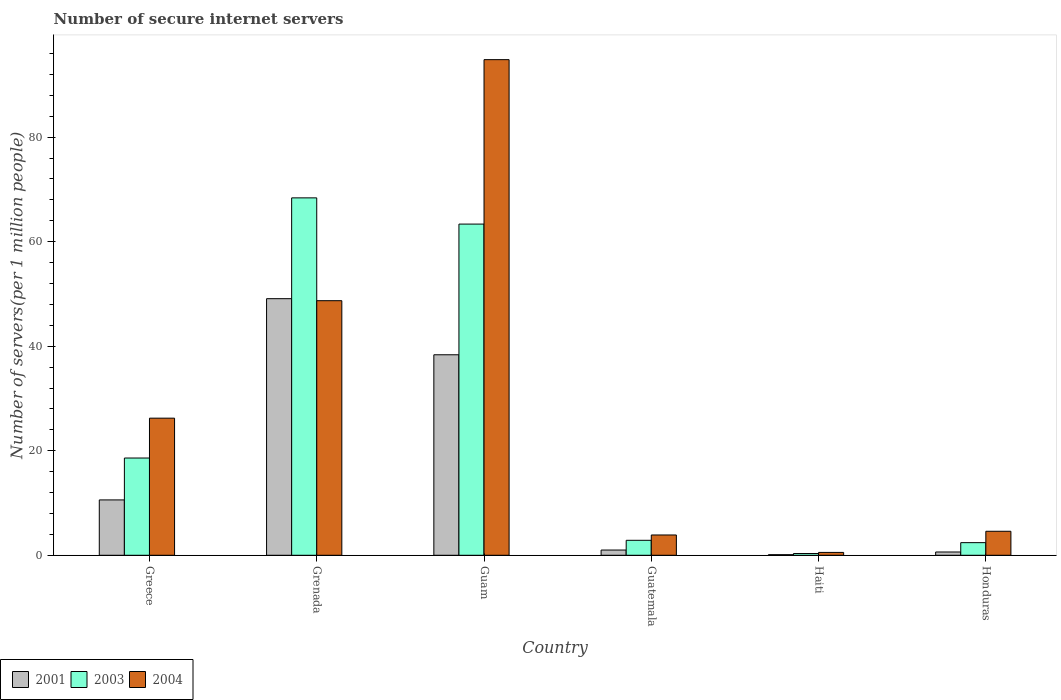Are the number of bars on each tick of the X-axis equal?
Your answer should be very brief. Yes. How many bars are there on the 4th tick from the right?
Offer a very short reply. 3. What is the label of the 3rd group of bars from the left?
Offer a terse response. Guam. What is the number of secure internet servers in 2004 in Guatemala?
Give a very brief answer. 3.88. Across all countries, what is the maximum number of secure internet servers in 2004?
Your answer should be compact. 94.82. Across all countries, what is the minimum number of secure internet servers in 2003?
Your answer should be compact. 0.33. In which country was the number of secure internet servers in 2003 maximum?
Keep it short and to the point. Grenada. In which country was the number of secure internet servers in 2003 minimum?
Your response must be concise. Haiti. What is the total number of secure internet servers in 2004 in the graph?
Offer a very short reply. 178.78. What is the difference between the number of secure internet servers in 2004 in Haiti and that in Honduras?
Give a very brief answer. -4.04. What is the difference between the number of secure internet servers in 2003 in Guam and the number of secure internet servers in 2001 in Grenada?
Keep it short and to the point. 14.27. What is the average number of secure internet servers in 2003 per country?
Provide a short and direct response. 25.99. What is the difference between the number of secure internet servers of/in 2004 and number of secure internet servers of/in 2003 in Haiti?
Your answer should be compact. 0.21. In how many countries, is the number of secure internet servers in 2004 greater than 80?
Provide a short and direct response. 1. What is the ratio of the number of secure internet servers in 2001 in Grenada to that in Guatemala?
Offer a terse response. 49. Is the number of secure internet servers in 2003 in Guatemala less than that in Haiti?
Offer a terse response. No. What is the difference between the highest and the second highest number of secure internet servers in 2004?
Offer a very short reply. 22.48. What is the difference between the highest and the lowest number of secure internet servers in 2004?
Make the answer very short. 94.27. Is the sum of the number of secure internet servers in 2001 in Greece and Grenada greater than the maximum number of secure internet servers in 2004 across all countries?
Provide a succinct answer. No. What does the 1st bar from the left in Greece represents?
Your answer should be compact. 2001. What does the 3rd bar from the right in Guatemala represents?
Your response must be concise. 2001. How many bars are there?
Offer a terse response. 18. What is the difference between two consecutive major ticks on the Y-axis?
Make the answer very short. 20. Are the values on the major ticks of Y-axis written in scientific E-notation?
Provide a succinct answer. No. Does the graph contain grids?
Give a very brief answer. No. Where does the legend appear in the graph?
Offer a very short reply. Bottom left. How many legend labels are there?
Your answer should be compact. 3. How are the legend labels stacked?
Give a very brief answer. Horizontal. What is the title of the graph?
Your answer should be compact. Number of secure internet servers. What is the label or title of the X-axis?
Offer a terse response. Country. What is the label or title of the Y-axis?
Provide a short and direct response. Number of servers(per 1 million people). What is the Number of servers(per 1 million people) of 2001 in Greece?
Your answer should be compact. 10.59. What is the Number of servers(per 1 million people) in 2003 in Greece?
Provide a short and direct response. 18.61. What is the Number of servers(per 1 million people) of 2004 in Greece?
Your answer should be very brief. 26.23. What is the Number of servers(per 1 million people) of 2001 in Grenada?
Your answer should be compact. 49.09. What is the Number of servers(per 1 million people) of 2003 in Grenada?
Your answer should be compact. 68.38. What is the Number of servers(per 1 million people) in 2004 in Grenada?
Offer a very short reply. 48.71. What is the Number of servers(per 1 million people) of 2001 in Guam?
Keep it short and to the point. 38.36. What is the Number of servers(per 1 million people) of 2003 in Guam?
Offer a very short reply. 63.36. What is the Number of servers(per 1 million people) of 2004 in Guam?
Your answer should be very brief. 94.82. What is the Number of servers(per 1 million people) in 2001 in Guatemala?
Give a very brief answer. 1. What is the Number of servers(per 1 million people) in 2003 in Guatemala?
Offer a terse response. 2.86. What is the Number of servers(per 1 million people) of 2004 in Guatemala?
Keep it short and to the point. 3.88. What is the Number of servers(per 1 million people) of 2001 in Haiti?
Your answer should be very brief. 0.12. What is the Number of servers(per 1 million people) in 2003 in Haiti?
Your answer should be compact. 0.33. What is the Number of servers(per 1 million people) in 2004 in Haiti?
Provide a succinct answer. 0.55. What is the Number of servers(per 1 million people) of 2001 in Honduras?
Your response must be concise. 0.63. What is the Number of servers(per 1 million people) in 2003 in Honduras?
Make the answer very short. 2.41. What is the Number of servers(per 1 million people) of 2004 in Honduras?
Your answer should be very brief. 4.59. Across all countries, what is the maximum Number of servers(per 1 million people) in 2001?
Give a very brief answer. 49.09. Across all countries, what is the maximum Number of servers(per 1 million people) in 2003?
Offer a very short reply. 68.38. Across all countries, what is the maximum Number of servers(per 1 million people) of 2004?
Provide a short and direct response. 94.82. Across all countries, what is the minimum Number of servers(per 1 million people) of 2001?
Your response must be concise. 0.12. Across all countries, what is the minimum Number of servers(per 1 million people) of 2003?
Ensure brevity in your answer.  0.33. Across all countries, what is the minimum Number of servers(per 1 million people) in 2004?
Provide a succinct answer. 0.55. What is the total Number of servers(per 1 million people) in 2001 in the graph?
Make the answer very short. 99.79. What is the total Number of servers(per 1 million people) of 2003 in the graph?
Offer a terse response. 155.96. What is the total Number of servers(per 1 million people) of 2004 in the graph?
Make the answer very short. 178.78. What is the difference between the Number of servers(per 1 million people) of 2001 in Greece and that in Grenada?
Provide a succinct answer. -38.5. What is the difference between the Number of servers(per 1 million people) of 2003 in Greece and that in Grenada?
Your answer should be compact. -49.77. What is the difference between the Number of servers(per 1 million people) in 2004 in Greece and that in Grenada?
Keep it short and to the point. -22.48. What is the difference between the Number of servers(per 1 million people) of 2001 in Greece and that in Guam?
Make the answer very short. -27.77. What is the difference between the Number of servers(per 1 million people) in 2003 in Greece and that in Guam?
Make the answer very short. -44.76. What is the difference between the Number of servers(per 1 million people) of 2004 in Greece and that in Guam?
Offer a terse response. -68.59. What is the difference between the Number of servers(per 1 million people) of 2001 in Greece and that in Guatemala?
Give a very brief answer. 9.59. What is the difference between the Number of servers(per 1 million people) in 2003 in Greece and that in Guatemala?
Offer a terse response. 15.74. What is the difference between the Number of servers(per 1 million people) in 2004 in Greece and that in Guatemala?
Ensure brevity in your answer.  22.35. What is the difference between the Number of servers(per 1 million people) of 2001 in Greece and that in Haiti?
Provide a succinct answer. 10.48. What is the difference between the Number of servers(per 1 million people) of 2003 in Greece and that in Haiti?
Your answer should be very brief. 18.27. What is the difference between the Number of servers(per 1 million people) of 2004 in Greece and that in Haiti?
Give a very brief answer. 25.68. What is the difference between the Number of servers(per 1 million people) of 2001 in Greece and that in Honduras?
Keep it short and to the point. 9.96. What is the difference between the Number of servers(per 1 million people) in 2003 in Greece and that in Honduras?
Make the answer very short. 16.19. What is the difference between the Number of servers(per 1 million people) of 2004 in Greece and that in Honduras?
Provide a succinct answer. 21.64. What is the difference between the Number of servers(per 1 million people) of 2001 in Grenada and that in Guam?
Offer a terse response. 10.73. What is the difference between the Number of servers(per 1 million people) of 2003 in Grenada and that in Guam?
Provide a short and direct response. 5.02. What is the difference between the Number of servers(per 1 million people) in 2004 in Grenada and that in Guam?
Ensure brevity in your answer.  -46.11. What is the difference between the Number of servers(per 1 million people) in 2001 in Grenada and that in Guatemala?
Your answer should be very brief. 48.09. What is the difference between the Number of servers(per 1 million people) in 2003 in Grenada and that in Guatemala?
Your answer should be very brief. 65.52. What is the difference between the Number of servers(per 1 million people) of 2004 in Grenada and that in Guatemala?
Your answer should be compact. 44.82. What is the difference between the Number of servers(per 1 million people) in 2001 in Grenada and that in Haiti?
Give a very brief answer. 48.98. What is the difference between the Number of servers(per 1 million people) of 2003 in Grenada and that in Haiti?
Your answer should be compact. 68.04. What is the difference between the Number of servers(per 1 million people) of 2004 in Grenada and that in Haiti?
Provide a succinct answer. 48.16. What is the difference between the Number of servers(per 1 million people) in 2001 in Grenada and that in Honduras?
Your response must be concise. 48.46. What is the difference between the Number of servers(per 1 million people) in 2003 in Grenada and that in Honduras?
Make the answer very short. 65.96. What is the difference between the Number of servers(per 1 million people) in 2004 in Grenada and that in Honduras?
Your answer should be compact. 44.12. What is the difference between the Number of servers(per 1 million people) of 2001 in Guam and that in Guatemala?
Offer a terse response. 37.36. What is the difference between the Number of servers(per 1 million people) of 2003 in Guam and that in Guatemala?
Give a very brief answer. 60.5. What is the difference between the Number of servers(per 1 million people) of 2004 in Guam and that in Guatemala?
Ensure brevity in your answer.  90.94. What is the difference between the Number of servers(per 1 million people) in 2001 in Guam and that in Haiti?
Provide a short and direct response. 38.24. What is the difference between the Number of servers(per 1 million people) of 2003 in Guam and that in Haiti?
Give a very brief answer. 63.03. What is the difference between the Number of servers(per 1 million people) of 2004 in Guam and that in Haiti?
Your answer should be compact. 94.27. What is the difference between the Number of servers(per 1 million people) in 2001 in Guam and that in Honduras?
Keep it short and to the point. 37.73. What is the difference between the Number of servers(per 1 million people) of 2003 in Guam and that in Honduras?
Your answer should be compact. 60.95. What is the difference between the Number of servers(per 1 million people) in 2004 in Guam and that in Honduras?
Your response must be concise. 90.23. What is the difference between the Number of servers(per 1 million people) of 2001 in Guatemala and that in Haiti?
Make the answer very short. 0.89. What is the difference between the Number of servers(per 1 million people) in 2003 in Guatemala and that in Haiti?
Give a very brief answer. 2.53. What is the difference between the Number of servers(per 1 million people) in 2004 in Guatemala and that in Haiti?
Your answer should be compact. 3.33. What is the difference between the Number of servers(per 1 million people) in 2001 in Guatemala and that in Honduras?
Keep it short and to the point. 0.37. What is the difference between the Number of servers(per 1 million people) of 2003 in Guatemala and that in Honduras?
Ensure brevity in your answer.  0.45. What is the difference between the Number of servers(per 1 million people) of 2004 in Guatemala and that in Honduras?
Ensure brevity in your answer.  -0.71. What is the difference between the Number of servers(per 1 million people) of 2001 in Haiti and that in Honduras?
Offer a very short reply. -0.51. What is the difference between the Number of servers(per 1 million people) of 2003 in Haiti and that in Honduras?
Offer a terse response. -2.08. What is the difference between the Number of servers(per 1 million people) in 2004 in Haiti and that in Honduras?
Provide a short and direct response. -4.04. What is the difference between the Number of servers(per 1 million people) in 2001 in Greece and the Number of servers(per 1 million people) in 2003 in Grenada?
Provide a succinct answer. -57.79. What is the difference between the Number of servers(per 1 million people) of 2001 in Greece and the Number of servers(per 1 million people) of 2004 in Grenada?
Offer a very short reply. -38.11. What is the difference between the Number of servers(per 1 million people) in 2003 in Greece and the Number of servers(per 1 million people) in 2004 in Grenada?
Provide a short and direct response. -30.1. What is the difference between the Number of servers(per 1 million people) in 2001 in Greece and the Number of servers(per 1 million people) in 2003 in Guam?
Provide a succinct answer. -52.77. What is the difference between the Number of servers(per 1 million people) of 2001 in Greece and the Number of servers(per 1 million people) of 2004 in Guam?
Provide a succinct answer. -84.23. What is the difference between the Number of servers(per 1 million people) of 2003 in Greece and the Number of servers(per 1 million people) of 2004 in Guam?
Provide a short and direct response. -76.21. What is the difference between the Number of servers(per 1 million people) in 2001 in Greece and the Number of servers(per 1 million people) in 2003 in Guatemala?
Provide a short and direct response. 7.73. What is the difference between the Number of servers(per 1 million people) in 2001 in Greece and the Number of servers(per 1 million people) in 2004 in Guatemala?
Ensure brevity in your answer.  6.71. What is the difference between the Number of servers(per 1 million people) of 2003 in Greece and the Number of servers(per 1 million people) of 2004 in Guatemala?
Your answer should be compact. 14.72. What is the difference between the Number of servers(per 1 million people) of 2001 in Greece and the Number of servers(per 1 million people) of 2003 in Haiti?
Keep it short and to the point. 10.26. What is the difference between the Number of servers(per 1 million people) of 2001 in Greece and the Number of servers(per 1 million people) of 2004 in Haiti?
Offer a very short reply. 10.04. What is the difference between the Number of servers(per 1 million people) in 2003 in Greece and the Number of servers(per 1 million people) in 2004 in Haiti?
Your response must be concise. 18.06. What is the difference between the Number of servers(per 1 million people) in 2001 in Greece and the Number of servers(per 1 million people) in 2003 in Honduras?
Make the answer very short. 8.18. What is the difference between the Number of servers(per 1 million people) in 2001 in Greece and the Number of servers(per 1 million people) in 2004 in Honduras?
Ensure brevity in your answer.  6. What is the difference between the Number of servers(per 1 million people) of 2003 in Greece and the Number of servers(per 1 million people) of 2004 in Honduras?
Give a very brief answer. 14.02. What is the difference between the Number of servers(per 1 million people) of 2001 in Grenada and the Number of servers(per 1 million people) of 2003 in Guam?
Offer a terse response. -14.27. What is the difference between the Number of servers(per 1 million people) in 2001 in Grenada and the Number of servers(per 1 million people) in 2004 in Guam?
Your answer should be compact. -45.73. What is the difference between the Number of servers(per 1 million people) of 2003 in Grenada and the Number of servers(per 1 million people) of 2004 in Guam?
Keep it short and to the point. -26.44. What is the difference between the Number of servers(per 1 million people) of 2001 in Grenada and the Number of servers(per 1 million people) of 2003 in Guatemala?
Your answer should be compact. 46.23. What is the difference between the Number of servers(per 1 million people) in 2001 in Grenada and the Number of servers(per 1 million people) in 2004 in Guatemala?
Offer a terse response. 45.21. What is the difference between the Number of servers(per 1 million people) in 2003 in Grenada and the Number of servers(per 1 million people) in 2004 in Guatemala?
Offer a very short reply. 64.5. What is the difference between the Number of servers(per 1 million people) in 2001 in Grenada and the Number of servers(per 1 million people) in 2003 in Haiti?
Provide a succinct answer. 48.76. What is the difference between the Number of servers(per 1 million people) of 2001 in Grenada and the Number of servers(per 1 million people) of 2004 in Haiti?
Give a very brief answer. 48.54. What is the difference between the Number of servers(per 1 million people) in 2003 in Grenada and the Number of servers(per 1 million people) in 2004 in Haiti?
Your answer should be very brief. 67.83. What is the difference between the Number of servers(per 1 million people) in 2001 in Grenada and the Number of servers(per 1 million people) in 2003 in Honduras?
Your answer should be very brief. 46.68. What is the difference between the Number of servers(per 1 million people) in 2001 in Grenada and the Number of servers(per 1 million people) in 2004 in Honduras?
Your answer should be compact. 44.5. What is the difference between the Number of servers(per 1 million people) in 2003 in Grenada and the Number of servers(per 1 million people) in 2004 in Honduras?
Your answer should be very brief. 63.79. What is the difference between the Number of servers(per 1 million people) of 2001 in Guam and the Number of servers(per 1 million people) of 2003 in Guatemala?
Keep it short and to the point. 35.5. What is the difference between the Number of servers(per 1 million people) of 2001 in Guam and the Number of servers(per 1 million people) of 2004 in Guatemala?
Offer a terse response. 34.48. What is the difference between the Number of servers(per 1 million people) in 2003 in Guam and the Number of servers(per 1 million people) in 2004 in Guatemala?
Offer a very short reply. 59.48. What is the difference between the Number of servers(per 1 million people) of 2001 in Guam and the Number of servers(per 1 million people) of 2003 in Haiti?
Give a very brief answer. 38.02. What is the difference between the Number of servers(per 1 million people) in 2001 in Guam and the Number of servers(per 1 million people) in 2004 in Haiti?
Offer a very short reply. 37.81. What is the difference between the Number of servers(per 1 million people) in 2003 in Guam and the Number of servers(per 1 million people) in 2004 in Haiti?
Your response must be concise. 62.81. What is the difference between the Number of servers(per 1 million people) of 2001 in Guam and the Number of servers(per 1 million people) of 2003 in Honduras?
Your response must be concise. 35.94. What is the difference between the Number of servers(per 1 million people) in 2001 in Guam and the Number of servers(per 1 million people) in 2004 in Honduras?
Your answer should be very brief. 33.77. What is the difference between the Number of servers(per 1 million people) of 2003 in Guam and the Number of servers(per 1 million people) of 2004 in Honduras?
Your response must be concise. 58.77. What is the difference between the Number of servers(per 1 million people) in 2001 in Guatemala and the Number of servers(per 1 million people) in 2003 in Haiti?
Provide a succinct answer. 0.67. What is the difference between the Number of servers(per 1 million people) in 2001 in Guatemala and the Number of servers(per 1 million people) in 2004 in Haiti?
Ensure brevity in your answer.  0.45. What is the difference between the Number of servers(per 1 million people) in 2003 in Guatemala and the Number of servers(per 1 million people) in 2004 in Haiti?
Provide a short and direct response. 2.31. What is the difference between the Number of servers(per 1 million people) of 2001 in Guatemala and the Number of servers(per 1 million people) of 2003 in Honduras?
Offer a very short reply. -1.41. What is the difference between the Number of servers(per 1 million people) in 2001 in Guatemala and the Number of servers(per 1 million people) in 2004 in Honduras?
Offer a very short reply. -3.59. What is the difference between the Number of servers(per 1 million people) of 2003 in Guatemala and the Number of servers(per 1 million people) of 2004 in Honduras?
Your response must be concise. -1.73. What is the difference between the Number of servers(per 1 million people) of 2001 in Haiti and the Number of servers(per 1 million people) of 2003 in Honduras?
Keep it short and to the point. -2.3. What is the difference between the Number of servers(per 1 million people) in 2001 in Haiti and the Number of servers(per 1 million people) in 2004 in Honduras?
Your answer should be compact. -4.48. What is the difference between the Number of servers(per 1 million people) of 2003 in Haiti and the Number of servers(per 1 million people) of 2004 in Honduras?
Your answer should be compact. -4.26. What is the average Number of servers(per 1 million people) in 2001 per country?
Offer a terse response. 16.63. What is the average Number of servers(per 1 million people) in 2003 per country?
Provide a short and direct response. 25.99. What is the average Number of servers(per 1 million people) of 2004 per country?
Provide a succinct answer. 29.8. What is the difference between the Number of servers(per 1 million people) in 2001 and Number of servers(per 1 million people) in 2003 in Greece?
Give a very brief answer. -8.01. What is the difference between the Number of servers(per 1 million people) in 2001 and Number of servers(per 1 million people) in 2004 in Greece?
Provide a succinct answer. -15.64. What is the difference between the Number of servers(per 1 million people) of 2003 and Number of servers(per 1 million people) of 2004 in Greece?
Provide a succinct answer. -7.63. What is the difference between the Number of servers(per 1 million people) of 2001 and Number of servers(per 1 million people) of 2003 in Grenada?
Ensure brevity in your answer.  -19.29. What is the difference between the Number of servers(per 1 million people) in 2001 and Number of servers(per 1 million people) in 2004 in Grenada?
Your answer should be compact. 0.39. What is the difference between the Number of servers(per 1 million people) in 2003 and Number of servers(per 1 million people) in 2004 in Grenada?
Offer a very short reply. 19.67. What is the difference between the Number of servers(per 1 million people) in 2001 and Number of servers(per 1 million people) in 2003 in Guam?
Provide a succinct answer. -25. What is the difference between the Number of servers(per 1 million people) of 2001 and Number of servers(per 1 million people) of 2004 in Guam?
Keep it short and to the point. -56.46. What is the difference between the Number of servers(per 1 million people) in 2003 and Number of servers(per 1 million people) in 2004 in Guam?
Provide a succinct answer. -31.46. What is the difference between the Number of servers(per 1 million people) of 2001 and Number of servers(per 1 million people) of 2003 in Guatemala?
Your answer should be compact. -1.86. What is the difference between the Number of servers(per 1 million people) of 2001 and Number of servers(per 1 million people) of 2004 in Guatemala?
Ensure brevity in your answer.  -2.88. What is the difference between the Number of servers(per 1 million people) in 2003 and Number of servers(per 1 million people) in 2004 in Guatemala?
Your answer should be very brief. -1.02. What is the difference between the Number of servers(per 1 million people) of 2001 and Number of servers(per 1 million people) of 2003 in Haiti?
Your response must be concise. -0.22. What is the difference between the Number of servers(per 1 million people) in 2001 and Number of servers(per 1 million people) in 2004 in Haiti?
Your response must be concise. -0.43. What is the difference between the Number of servers(per 1 million people) in 2003 and Number of servers(per 1 million people) in 2004 in Haiti?
Your answer should be very brief. -0.21. What is the difference between the Number of servers(per 1 million people) in 2001 and Number of servers(per 1 million people) in 2003 in Honduras?
Ensure brevity in your answer.  -1.79. What is the difference between the Number of servers(per 1 million people) of 2001 and Number of servers(per 1 million people) of 2004 in Honduras?
Keep it short and to the point. -3.96. What is the difference between the Number of servers(per 1 million people) of 2003 and Number of servers(per 1 million people) of 2004 in Honduras?
Your answer should be compact. -2.18. What is the ratio of the Number of servers(per 1 million people) in 2001 in Greece to that in Grenada?
Your answer should be compact. 0.22. What is the ratio of the Number of servers(per 1 million people) in 2003 in Greece to that in Grenada?
Provide a short and direct response. 0.27. What is the ratio of the Number of servers(per 1 million people) in 2004 in Greece to that in Grenada?
Give a very brief answer. 0.54. What is the ratio of the Number of servers(per 1 million people) of 2001 in Greece to that in Guam?
Offer a very short reply. 0.28. What is the ratio of the Number of servers(per 1 million people) in 2003 in Greece to that in Guam?
Ensure brevity in your answer.  0.29. What is the ratio of the Number of servers(per 1 million people) in 2004 in Greece to that in Guam?
Give a very brief answer. 0.28. What is the ratio of the Number of servers(per 1 million people) in 2001 in Greece to that in Guatemala?
Offer a very short reply. 10.57. What is the ratio of the Number of servers(per 1 million people) of 2003 in Greece to that in Guatemala?
Your answer should be compact. 6.5. What is the ratio of the Number of servers(per 1 million people) in 2004 in Greece to that in Guatemala?
Your answer should be compact. 6.76. What is the ratio of the Number of servers(per 1 million people) of 2001 in Greece to that in Haiti?
Ensure brevity in your answer.  92.07. What is the ratio of the Number of servers(per 1 million people) of 2003 in Greece to that in Haiti?
Your response must be concise. 55.67. What is the ratio of the Number of servers(per 1 million people) in 2004 in Greece to that in Haiti?
Your answer should be very brief. 47.84. What is the ratio of the Number of servers(per 1 million people) in 2001 in Greece to that in Honduras?
Make the answer very short. 16.87. What is the ratio of the Number of servers(per 1 million people) of 2003 in Greece to that in Honduras?
Provide a short and direct response. 7.71. What is the ratio of the Number of servers(per 1 million people) in 2004 in Greece to that in Honduras?
Provide a short and direct response. 5.71. What is the ratio of the Number of servers(per 1 million people) in 2001 in Grenada to that in Guam?
Provide a succinct answer. 1.28. What is the ratio of the Number of servers(per 1 million people) of 2003 in Grenada to that in Guam?
Provide a succinct answer. 1.08. What is the ratio of the Number of servers(per 1 million people) in 2004 in Grenada to that in Guam?
Offer a very short reply. 0.51. What is the ratio of the Number of servers(per 1 million people) of 2001 in Grenada to that in Guatemala?
Provide a succinct answer. 49. What is the ratio of the Number of servers(per 1 million people) in 2003 in Grenada to that in Guatemala?
Give a very brief answer. 23.88. What is the ratio of the Number of servers(per 1 million people) of 2004 in Grenada to that in Guatemala?
Provide a short and direct response. 12.54. What is the ratio of the Number of servers(per 1 million people) in 2001 in Grenada to that in Haiti?
Your response must be concise. 426.74. What is the ratio of the Number of servers(per 1 million people) in 2003 in Grenada to that in Haiti?
Make the answer very short. 204.6. What is the ratio of the Number of servers(per 1 million people) in 2004 in Grenada to that in Haiti?
Your answer should be compact. 88.83. What is the ratio of the Number of servers(per 1 million people) in 2001 in Grenada to that in Honduras?
Provide a short and direct response. 78.2. What is the ratio of the Number of servers(per 1 million people) in 2003 in Grenada to that in Honduras?
Keep it short and to the point. 28.32. What is the ratio of the Number of servers(per 1 million people) of 2004 in Grenada to that in Honduras?
Keep it short and to the point. 10.61. What is the ratio of the Number of servers(per 1 million people) of 2001 in Guam to that in Guatemala?
Give a very brief answer. 38.28. What is the ratio of the Number of servers(per 1 million people) in 2003 in Guam to that in Guatemala?
Ensure brevity in your answer.  22.13. What is the ratio of the Number of servers(per 1 million people) in 2004 in Guam to that in Guatemala?
Ensure brevity in your answer.  24.42. What is the ratio of the Number of servers(per 1 million people) in 2001 in Guam to that in Haiti?
Your answer should be compact. 333.44. What is the ratio of the Number of servers(per 1 million people) in 2003 in Guam to that in Haiti?
Keep it short and to the point. 189.59. What is the ratio of the Number of servers(per 1 million people) of 2004 in Guam to that in Haiti?
Your answer should be compact. 172.94. What is the ratio of the Number of servers(per 1 million people) in 2001 in Guam to that in Honduras?
Give a very brief answer. 61.1. What is the ratio of the Number of servers(per 1 million people) of 2003 in Guam to that in Honduras?
Your response must be concise. 26.24. What is the ratio of the Number of servers(per 1 million people) in 2004 in Guam to that in Honduras?
Ensure brevity in your answer.  20.66. What is the ratio of the Number of servers(per 1 million people) of 2001 in Guatemala to that in Haiti?
Make the answer very short. 8.71. What is the ratio of the Number of servers(per 1 million people) in 2003 in Guatemala to that in Haiti?
Give a very brief answer. 8.57. What is the ratio of the Number of servers(per 1 million people) in 2004 in Guatemala to that in Haiti?
Your answer should be very brief. 7.08. What is the ratio of the Number of servers(per 1 million people) of 2001 in Guatemala to that in Honduras?
Make the answer very short. 1.6. What is the ratio of the Number of servers(per 1 million people) in 2003 in Guatemala to that in Honduras?
Make the answer very short. 1.19. What is the ratio of the Number of servers(per 1 million people) in 2004 in Guatemala to that in Honduras?
Ensure brevity in your answer.  0.85. What is the ratio of the Number of servers(per 1 million people) of 2001 in Haiti to that in Honduras?
Provide a succinct answer. 0.18. What is the ratio of the Number of servers(per 1 million people) in 2003 in Haiti to that in Honduras?
Your answer should be very brief. 0.14. What is the ratio of the Number of servers(per 1 million people) in 2004 in Haiti to that in Honduras?
Keep it short and to the point. 0.12. What is the difference between the highest and the second highest Number of servers(per 1 million people) of 2001?
Ensure brevity in your answer.  10.73. What is the difference between the highest and the second highest Number of servers(per 1 million people) of 2003?
Provide a succinct answer. 5.02. What is the difference between the highest and the second highest Number of servers(per 1 million people) of 2004?
Offer a terse response. 46.11. What is the difference between the highest and the lowest Number of servers(per 1 million people) in 2001?
Offer a very short reply. 48.98. What is the difference between the highest and the lowest Number of servers(per 1 million people) of 2003?
Your answer should be compact. 68.04. What is the difference between the highest and the lowest Number of servers(per 1 million people) in 2004?
Offer a very short reply. 94.27. 